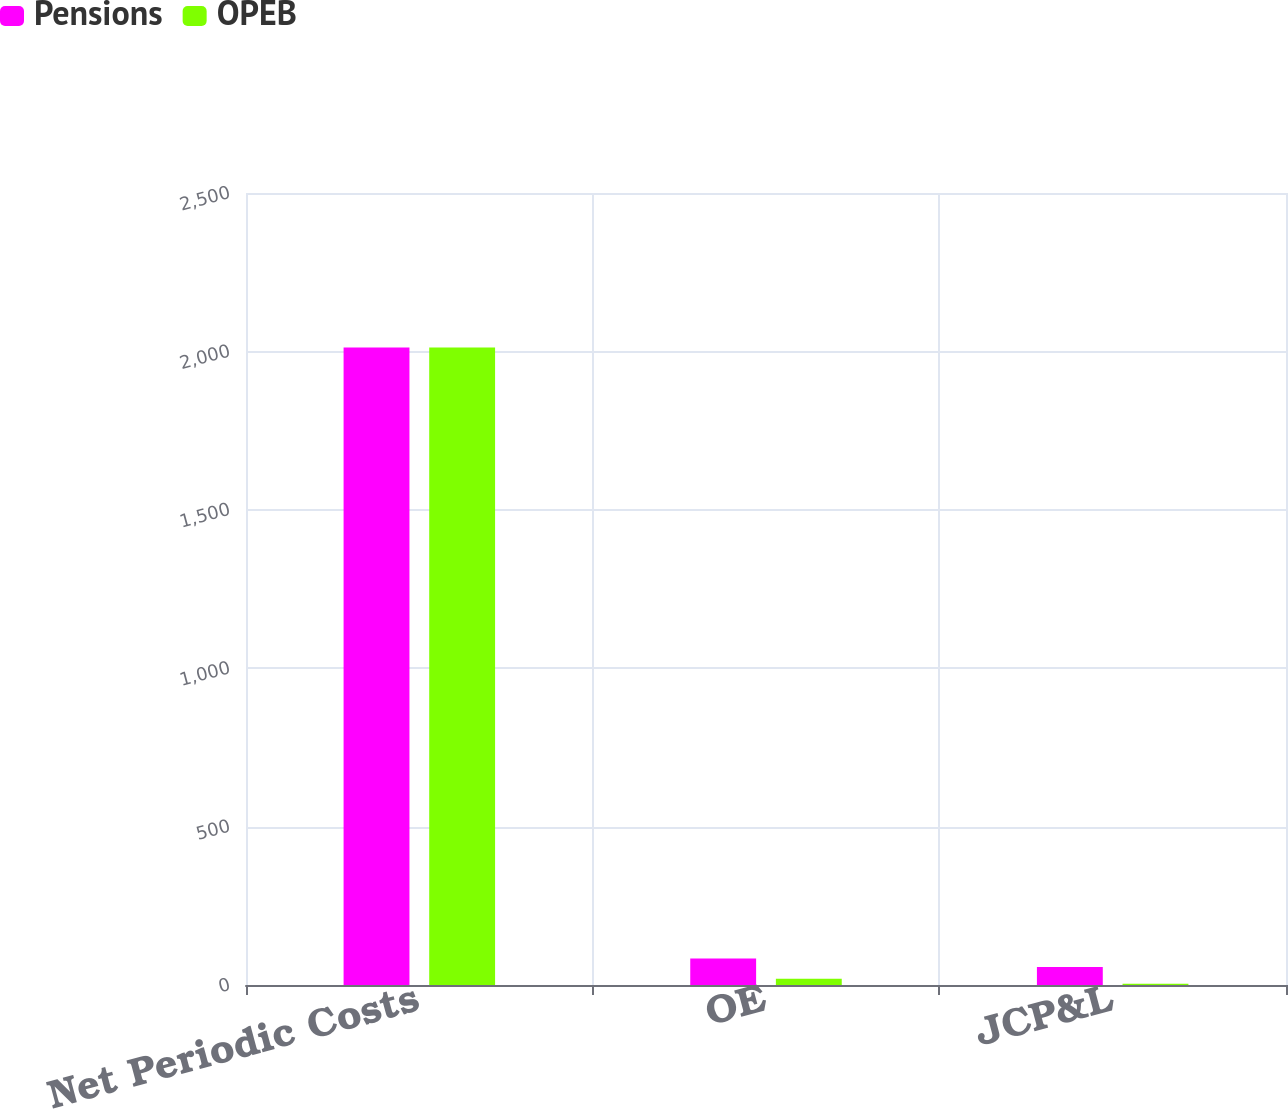Convert chart to OTSL. <chart><loc_0><loc_0><loc_500><loc_500><stacked_bar_chart><ecel><fcel>Net Periodic Costs<fcel>OE<fcel>JCP&L<nl><fcel>Pensions<fcel>2012<fcel>84<fcel>57<nl><fcel>OPEB<fcel>2012<fcel>20<fcel>4<nl></chart> 